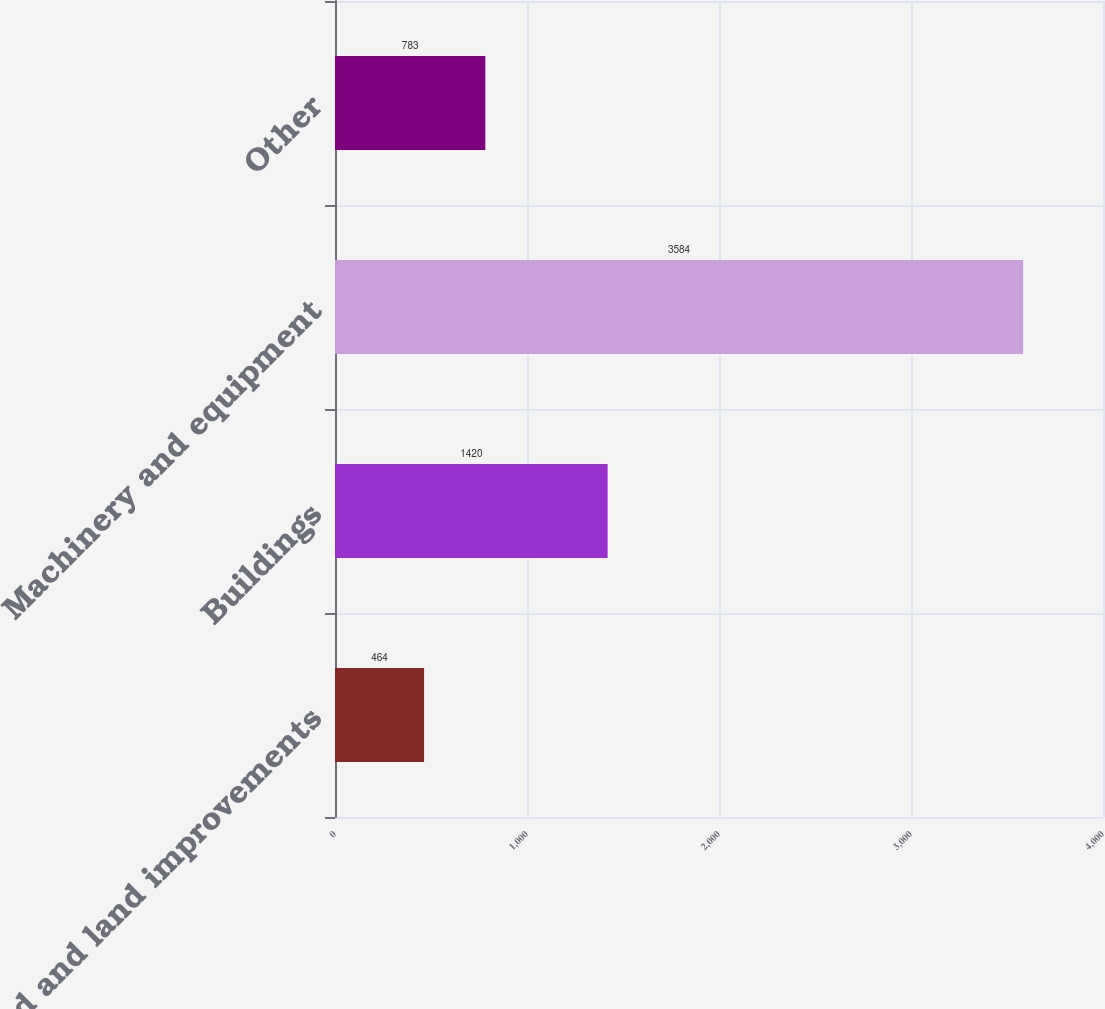Convert chart. <chart><loc_0><loc_0><loc_500><loc_500><bar_chart><fcel>Land and land improvements<fcel>Buildings<fcel>Machinery and equipment<fcel>Other<nl><fcel>464<fcel>1420<fcel>3584<fcel>783<nl></chart> 